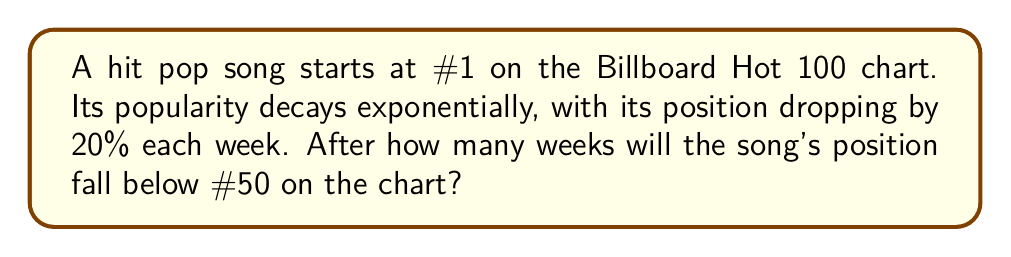What is the answer to this math problem? Let's approach this step-by-step:

1) The song starts at position 1 and we want to know when it falls below position 50.

2) Each week, the position increases (gets worse) by 20%. This means that each week, the position is multiplied by 1.2.

3) We can express this mathematically as:

   $1 \cdot 1.2^x > 50$

   Where $x$ is the number of weeks.

4) To solve this, we need to use logarithms:

   $\log_{1.2}(50) > x$

5) Using the change of base formula:

   $\frac{\log(50)}{\log(1.2)} > x$

6) Calculating this:

   $\frac{\log(50)}{\log(1.2)} \approx 10.67$

7) Since we can only have a whole number of weeks, we need to round up to 11.

Therefore, after 11 weeks, the song will fall below position 50 on the chart.
Answer: 11 weeks 